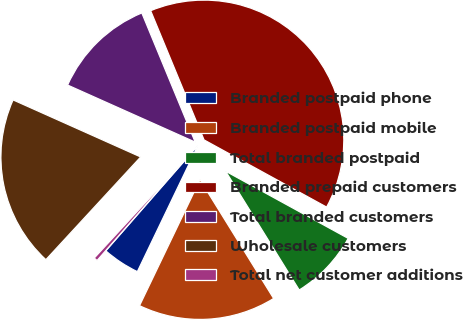Convert chart to OTSL. <chart><loc_0><loc_0><loc_500><loc_500><pie_chart><fcel>Branded postpaid phone<fcel>Branded postpaid mobile<fcel>Total branded postpaid<fcel>Branded prepaid customers<fcel>Total branded customers<fcel>Wholesale customers<fcel>Total net customer additions<nl><fcel>4.31%<fcel>15.95%<fcel>8.19%<fcel>39.22%<fcel>12.07%<fcel>19.83%<fcel>0.43%<nl></chart> 